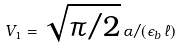Convert formula to latex. <formula><loc_0><loc_0><loc_500><loc_500>V _ { 1 } = \sqrt { \pi / 2 } \, \alpha / ( \epsilon _ { b } \, \ell )</formula> 